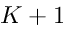Convert formula to latex. <formula><loc_0><loc_0><loc_500><loc_500>K + 1</formula> 